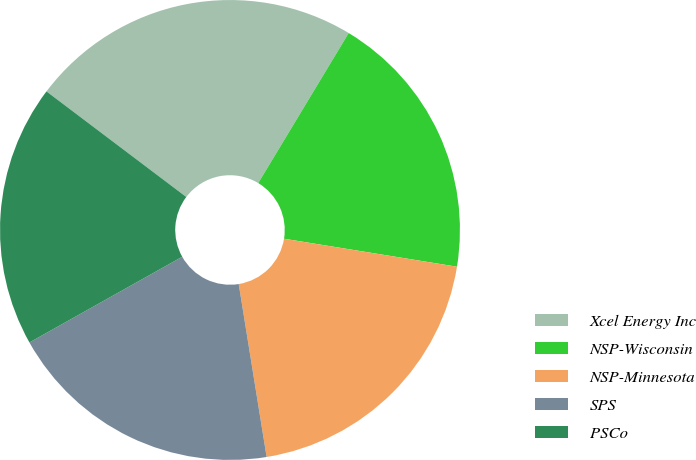Convert chart. <chart><loc_0><loc_0><loc_500><loc_500><pie_chart><fcel>Xcel Energy Inc<fcel>NSP-Wisconsin<fcel>NSP-Minnesota<fcel>SPS<fcel>PSCo<nl><fcel>23.34%<fcel>18.92%<fcel>19.9%<fcel>19.41%<fcel>18.43%<nl></chart> 